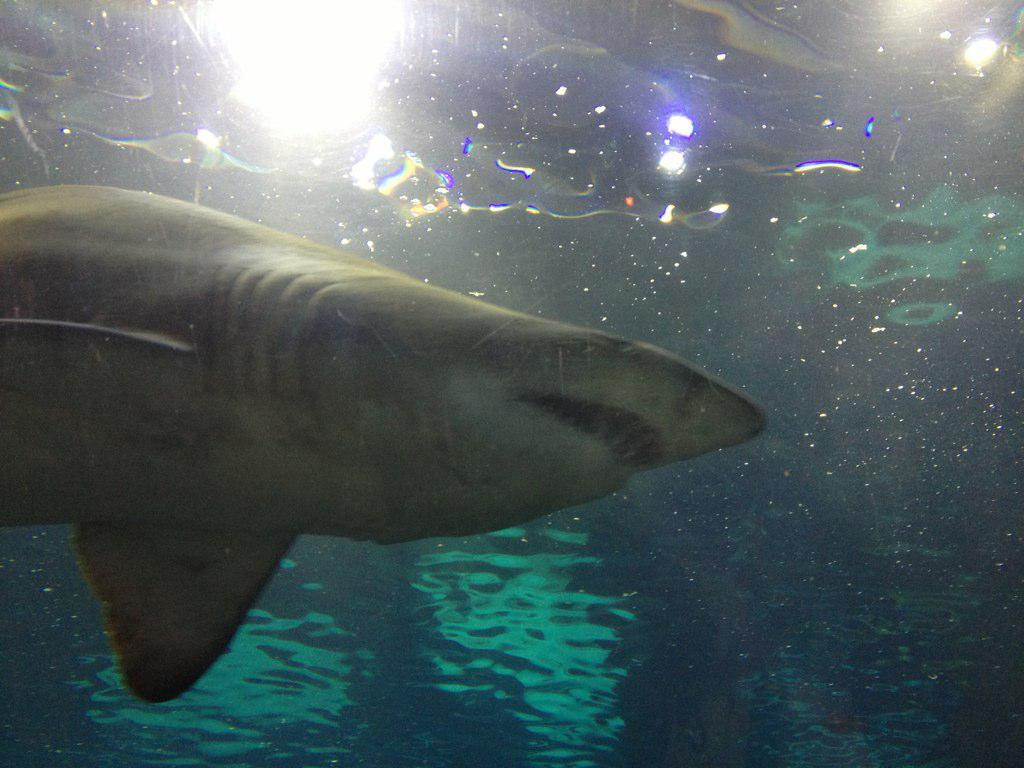What is the main subject of the image? The main subject of the image is a shark. What can be seen in the water in the image? Lights are present in the water in the image. How many mice can be seen playing with a cup in the image? There are no mice or cups present in the image. What type of amusement can be seen in the image? There is no amusement depicted in the image; it features a shark and lights in the water. 